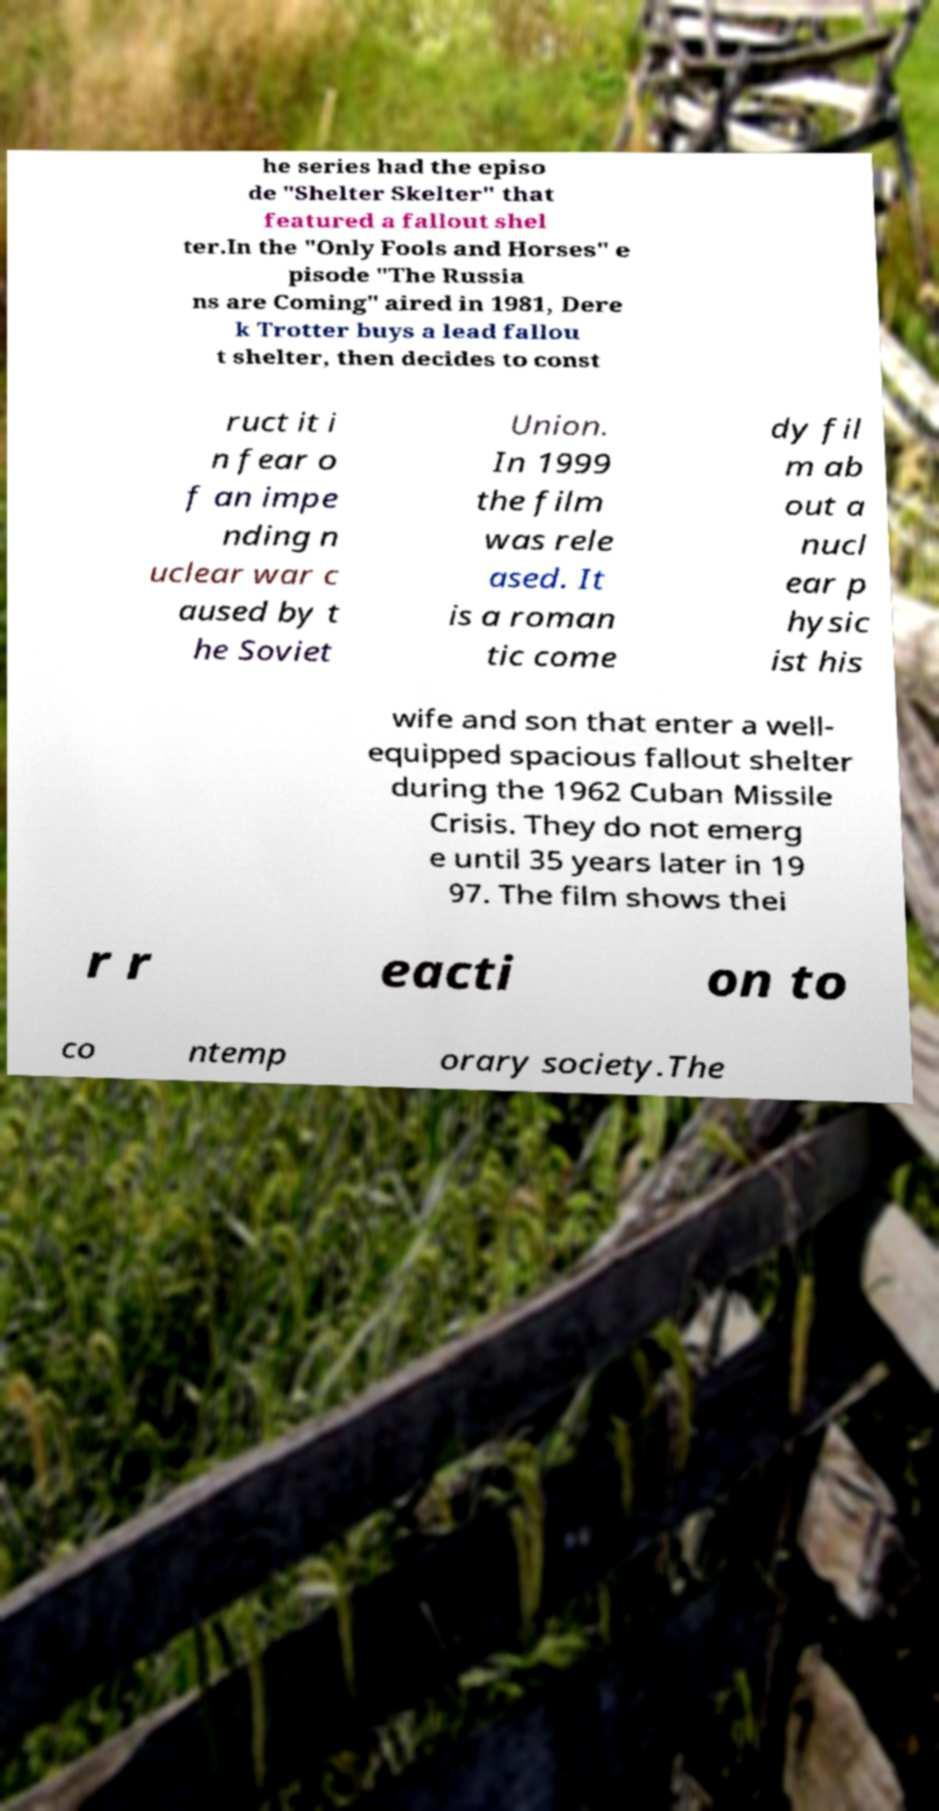Please identify and transcribe the text found in this image. he series had the episo de "Shelter Skelter" that featured a fallout shel ter.In the "Only Fools and Horses" e pisode "The Russia ns are Coming" aired in 1981, Dere k Trotter buys a lead fallou t shelter, then decides to const ruct it i n fear o f an impe nding n uclear war c aused by t he Soviet Union. In 1999 the film was rele ased. It is a roman tic come dy fil m ab out a nucl ear p hysic ist his wife and son that enter a well- equipped spacious fallout shelter during the 1962 Cuban Missile Crisis. They do not emerg e until 35 years later in 19 97. The film shows thei r r eacti on to co ntemp orary society.The 